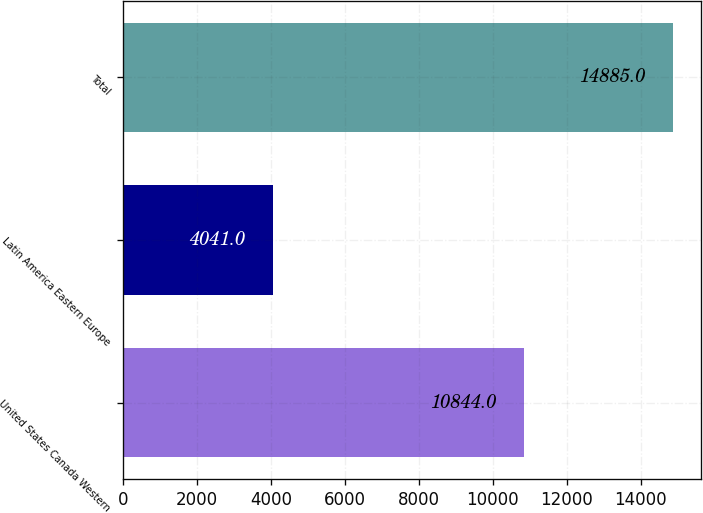<chart> <loc_0><loc_0><loc_500><loc_500><bar_chart><fcel>United States Canada Western<fcel>Latin America Eastern Europe<fcel>Total<nl><fcel>10844<fcel>4041<fcel>14885<nl></chart> 